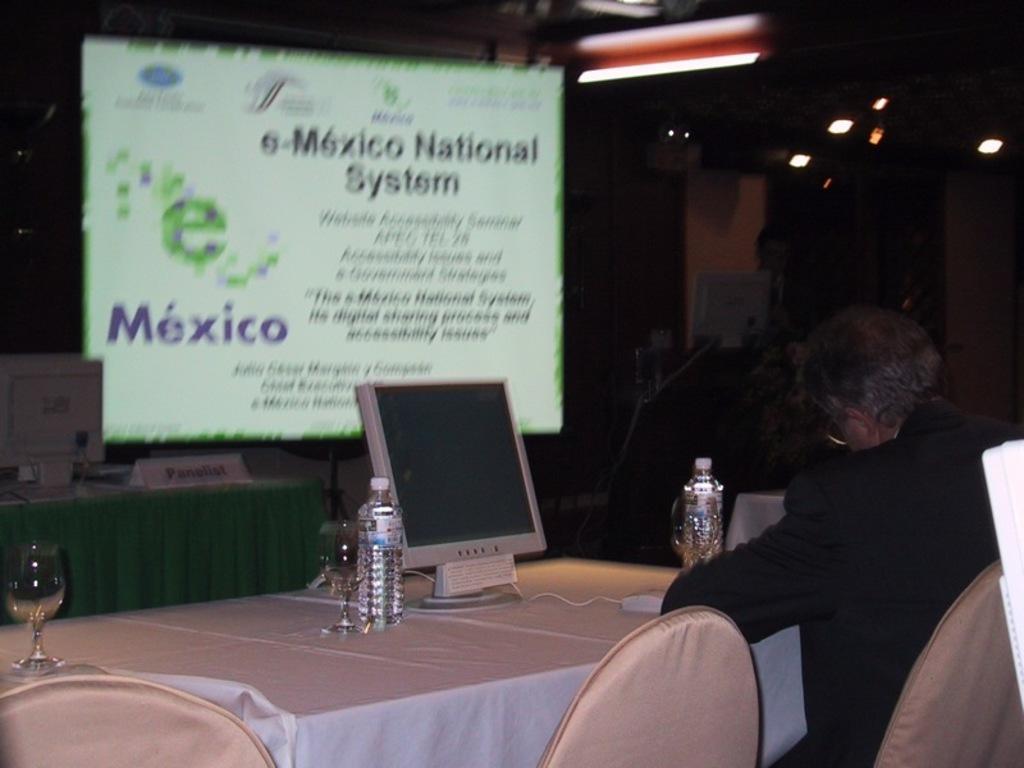In one or two sentences, can you explain what this image depicts? In this picture we can see a man sitting on the chair. This is the table. On the table there is a glass, bottle, and a monitor. And on the background there is a screen. And these are the lights. 